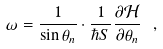<formula> <loc_0><loc_0><loc_500><loc_500>\omega = \frac { 1 } { \sin \theta _ { n } } \cdot \frac { 1 } { \hbar { S } } \frac { \partial \mathcal { H } } { \partial \theta _ { n } } \ ,</formula> 